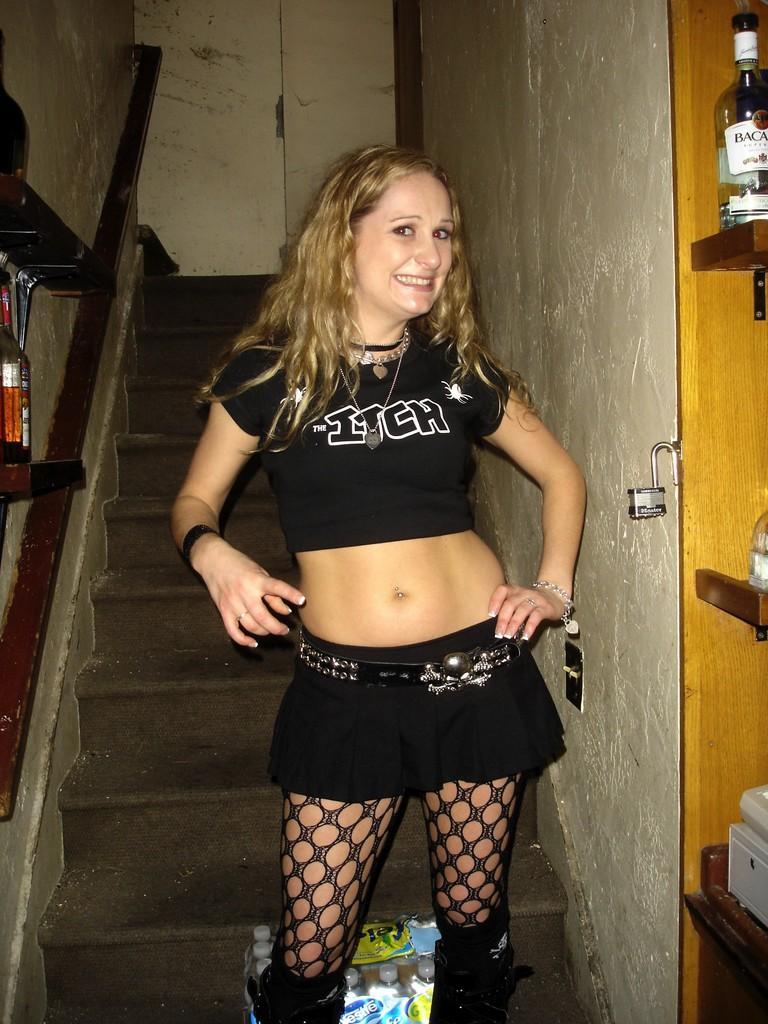Describe this image in one or two sentences. In this picture there is a woman with black dress is standing and smiling. At the back there is a staircase. On the right side of the image there is a bottle and there are objects in the shelf. On the left side of the image there are bottles in the shelf. At the bottom there are bottles on the staircase. 